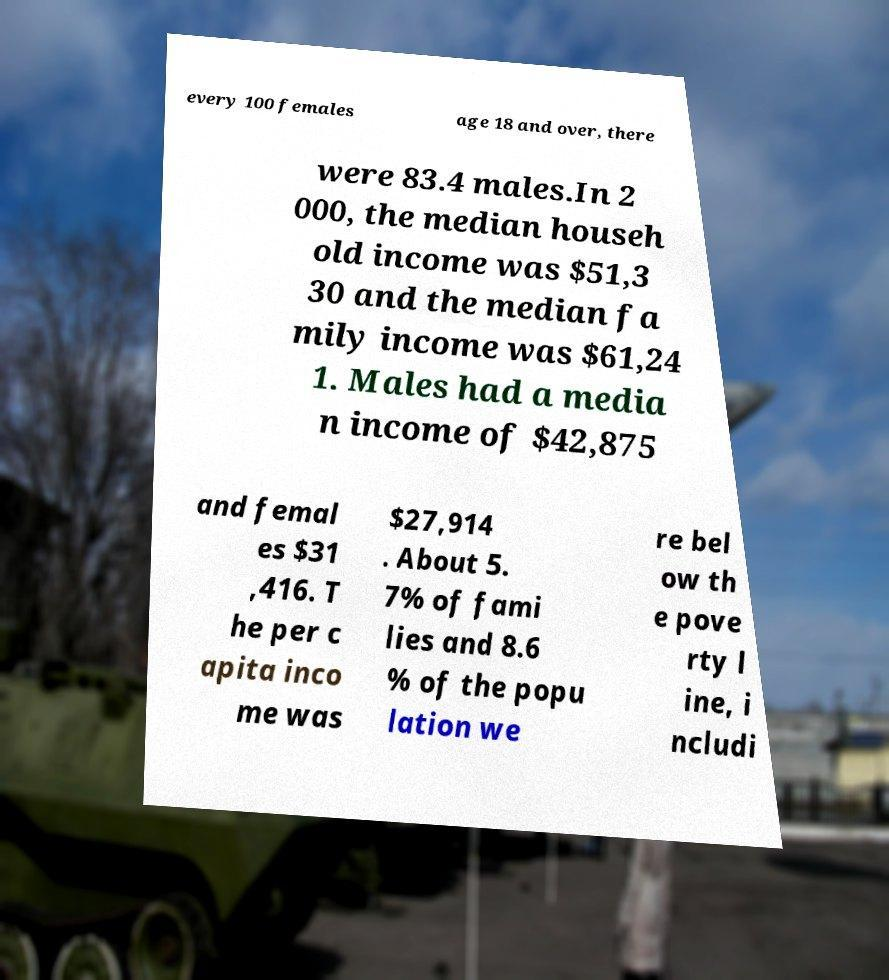Could you assist in decoding the text presented in this image and type it out clearly? every 100 females age 18 and over, there were 83.4 males.In 2 000, the median househ old income was $51,3 30 and the median fa mily income was $61,24 1. Males had a media n income of $42,875 and femal es $31 ,416. T he per c apita inco me was $27,914 . About 5. 7% of fami lies and 8.6 % of the popu lation we re bel ow th e pove rty l ine, i ncludi 